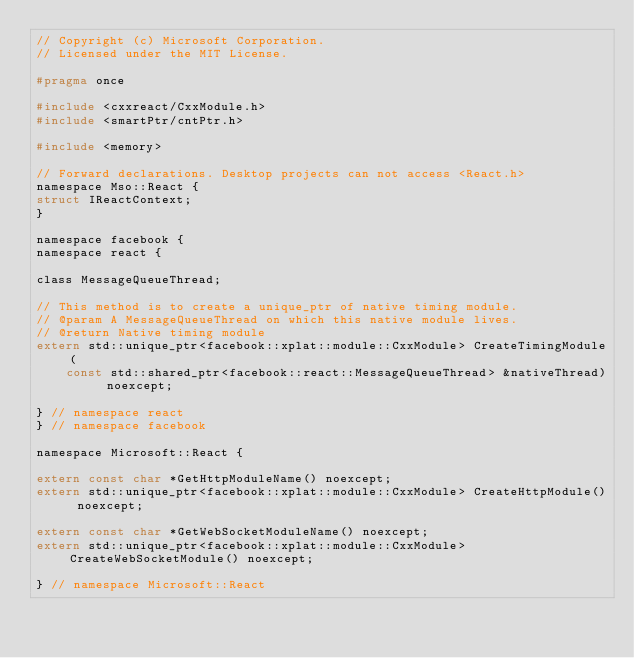Convert code to text. <code><loc_0><loc_0><loc_500><loc_500><_C_>// Copyright (c) Microsoft Corporation.
// Licensed under the MIT License.

#pragma once

#include <cxxreact/CxxModule.h>
#include <smartPtr/cntPtr.h>

#include <memory>

// Forward declarations. Desktop projects can not access <React.h>
namespace Mso::React {
struct IReactContext;
}

namespace facebook {
namespace react {

class MessageQueueThread;

// This method is to create a unique_ptr of native timing module.
// @param A MessageQueueThread on which this native module lives.
// @return Native timing module
extern std::unique_ptr<facebook::xplat::module::CxxModule> CreateTimingModule(
    const std::shared_ptr<facebook::react::MessageQueueThread> &nativeThread) noexcept;

} // namespace react
} // namespace facebook

namespace Microsoft::React {

extern const char *GetHttpModuleName() noexcept;
extern std::unique_ptr<facebook::xplat::module::CxxModule> CreateHttpModule() noexcept;

extern const char *GetWebSocketModuleName() noexcept;
extern std::unique_ptr<facebook::xplat::module::CxxModule> CreateWebSocketModule() noexcept;

} // namespace Microsoft::React
</code> 